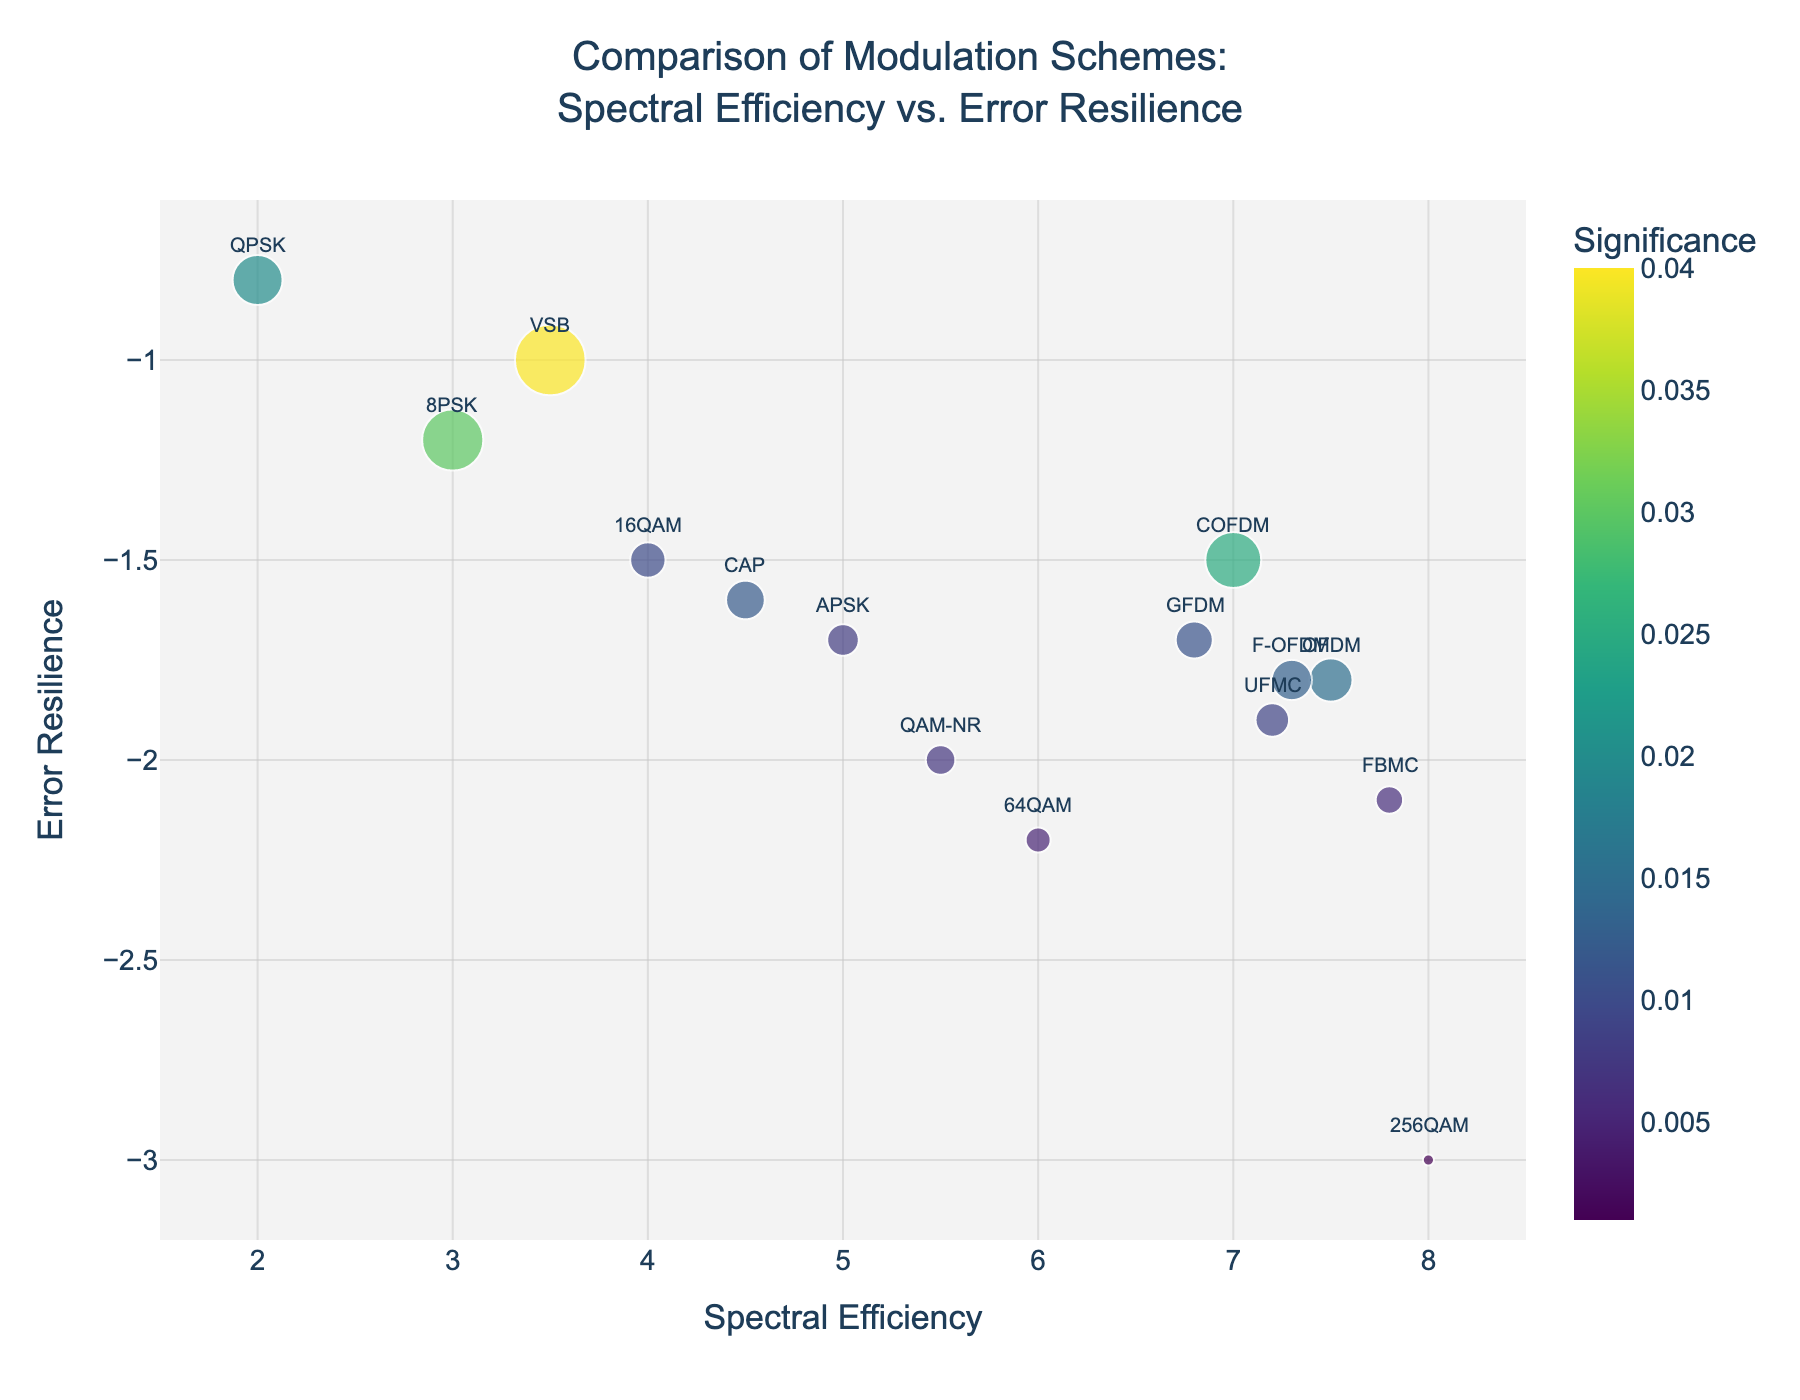What is the title of the plot? The title of the plot is usually located at the top and provides context for what the figure represents. In this plot, the title is clearly written at the top center.
Answer: Comparison of Modulation Schemes: Spectral Efficiency vs. Error Resilience What is the modulation scheme with the highest spectral efficiency? To find the modulation scheme with the highest spectral efficiency, look at the x-axis and identify the point furthest to the right. In this case, 256QAM is the farthest to the right.
Answer: 256QAM Which modulation scheme has the lowest error resilience? To determine the modulation scheme with the lowest error resilience, look for the point lowest on the y-axis. Here, 256QAM has the lowest point.
Answer: 256QAM How many modulation schemes are compared in this plot? Count the total number of data points or annotations in the plot. There are 15 different modulation schemes represented.
Answer: 15 Comparing QPSK and 16QAM, which has higher spectral efficiency and which has higher error resilience? Spectral efficiency is on the x-axis and error resilience on the y-axis. QPSK has a spectral efficiency of 2.0 and error resilience of -0.8. 16QAM has a spectral efficiency of 4.0 and error resilience of -1.5. Therefore, 16QAM has higher spectral efficiency, and QPSK has higher error resilience.
Answer: 16QAM (spectral efficiency), QPSK (error resilience) What is the median error resilience value in the figure? List all error resilience values and find the middle value. The values are: -0.8, -1.0, -1.2, -1.5, -1.5, -1.6, -1.7, -1.7, -1.8, -1.8, -1.9, -2.0, -2.1, -2.2, -3.0. The median value is the 8th one when sorted, which is -1.7.
Answer: -1.7 Which modulation scheme has the lowest significance and what is its error resilience? The size of the points represents significance, so the smallest point indicates the lowest significance. This corresponds to 256QAM with a significance of 0.001. Its error resilience is -3.0.
Answer: 256QAM, -3.0 Are there any modulation schemes with identical error resilience? If so, which ones? Identify any points that share the same value on the y-axis (Error Resilience). Here, we can see that both 16QAM and COFDM have an error resilience of -1.5, and APSK and GFDM have an error resilience of -1.7.
Answer: 16QAM and COFDM; APSK and GFDM What is the difference in error resilience between FBMC and UFMC? Look up the error resilience values for FBMC and UFMC and then subtract them. FBMC has an error resilience of -2.1, and UFMC has -1.9. The difference is -2.1 - (-1.9) = -0.2.
Answer: -0.2 